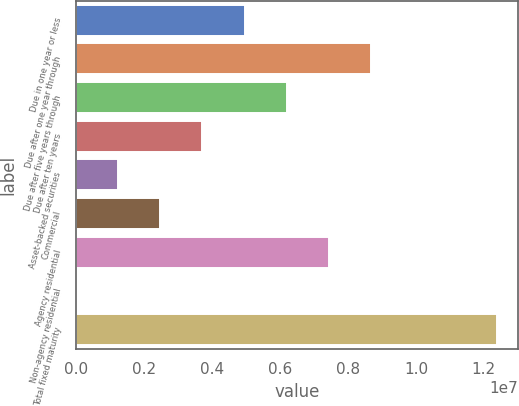Convert chart to OTSL. <chart><loc_0><loc_0><loc_500><loc_500><bar_chart><fcel>Due in one year or less<fcel>Due after one year through<fcel>Due after five years through<fcel>Due after ten years<fcel>Asset-backed securities<fcel>Commercial<fcel>Agency residential<fcel>Non-agency residential<fcel>Total fixed maturity<nl><fcel>4.95936e+06<fcel>8.67526e+06<fcel>6.19799e+06<fcel>3.72072e+06<fcel>1.24345e+06<fcel>2.48209e+06<fcel>7.43662e+06<fcel>4816<fcel>1.23912e+07<nl></chart> 